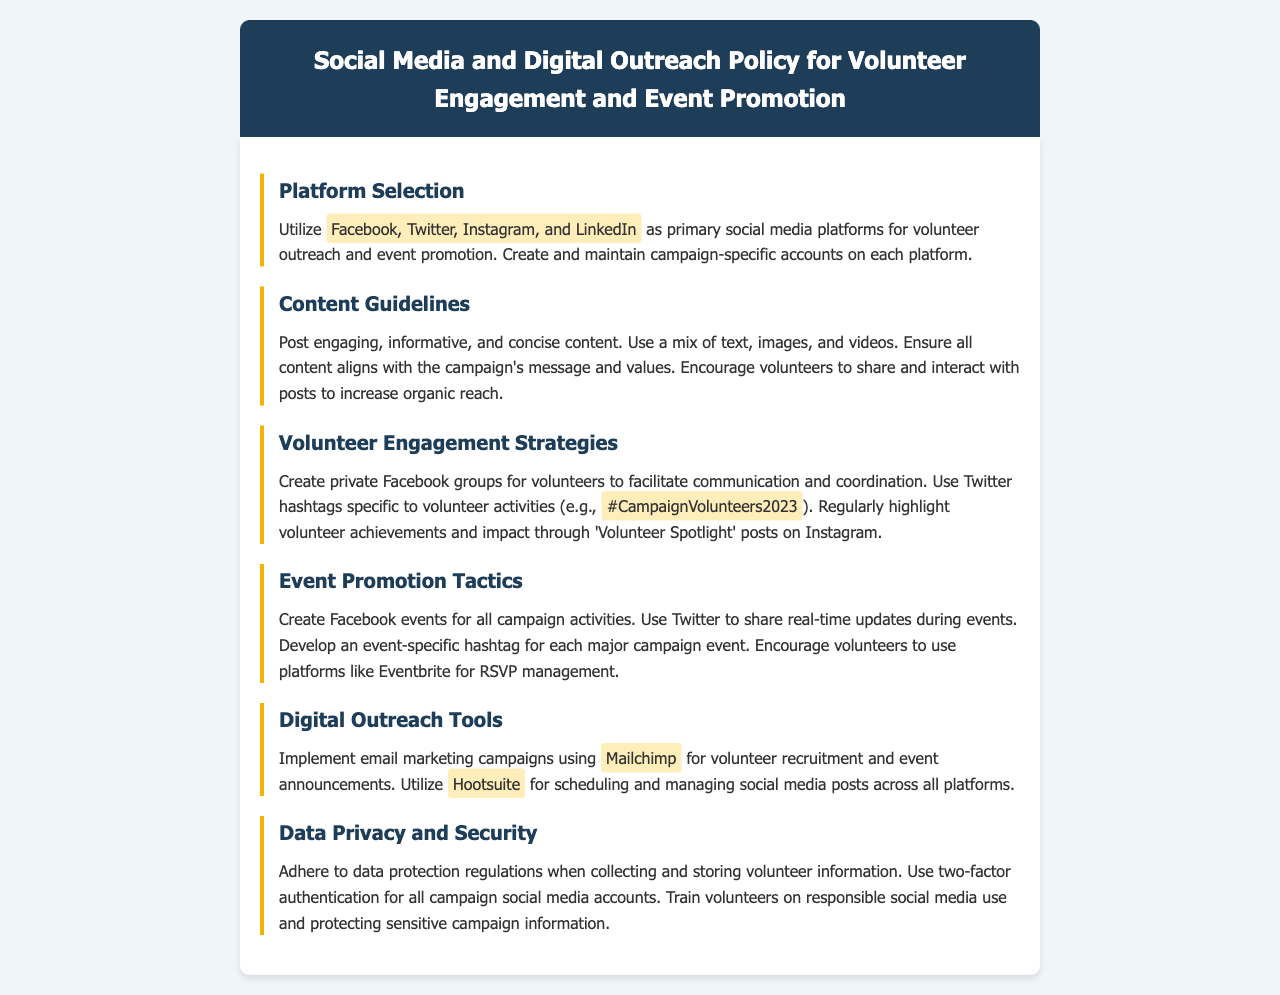What are the primary social media platforms for outreach? The document specifies Facebook, Twitter, Instagram, and LinkedIn as the primary platforms for volunteer outreach and event promotion.
Answer: Facebook, Twitter, Instagram, and LinkedIn What is the recommended tool for email marketing campaigns? Mailchimp is mentioned in the document as the tool for implementing email marketing campaigns for volunteer recruitment and event announcements.
Answer: Mailchimp What specific hashtag is suggested for volunteer activities? The document lists #CampaignVolunteers2023 as a Twitter hashtag for volunteer activities.
Answer: #CampaignVolunteers2023 What is a recommended strategy for volunteer engagement? The policy advises creating private Facebook groups as a strategy for facilitating communication and coordination among volunteers.
Answer: Private Facebook groups How should event updates be shared during campaigns? The document states that Twitter should be used to share real-time updates during events.
Answer: Twitter What aspect of volunteer information must be adhered to? The document highlights the importance of adhering to data protection regulations when collecting and storing volunteer information.
Answer: Data protection regulations Which tool is suggested for managing social media posts? Hootsuite is mentioned as the tool for scheduling and managing social media posts across all platforms.
Answer: Hootsuite What type of content should be posted? The document recommends posting engaging, informative, and concise content that aligns with the campaign's message and values.
Answer: Engaging, informative, and concise content 